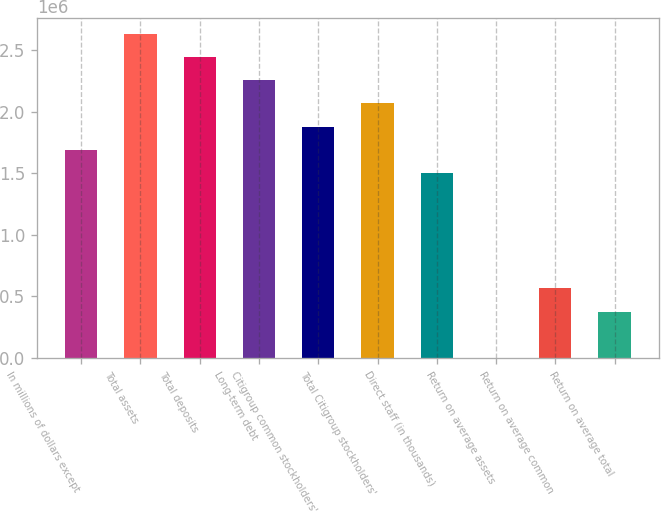Convert chart. <chart><loc_0><loc_0><loc_500><loc_500><bar_chart><fcel>In millions of dollars except<fcel>Total assets<fcel>Total deposits<fcel>Long-term debt<fcel>Citigroup common stockholders'<fcel>Total Citigroup stockholders'<fcel>Direct staff (in thousands)<fcel>Return on average assets<fcel>Return on average common<fcel>Return on average total<nl><fcel>1.69203e+06<fcel>2.63205e+06<fcel>2.44405e+06<fcel>2.25604e+06<fcel>1.88004e+06<fcel>2.06804e+06<fcel>1.50403e+06<fcel>0.73<fcel>564011<fcel>376008<nl></chart> 